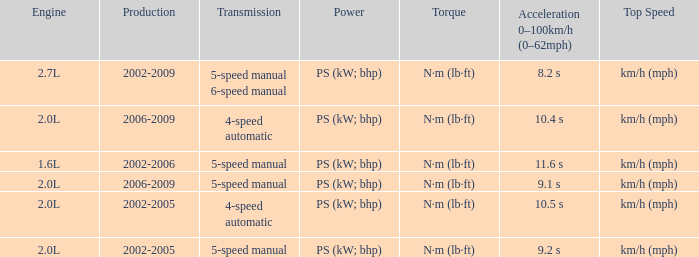What is the top speed of a 5-speed manual transmission produced in 2006-2009? Km/h (mph). 